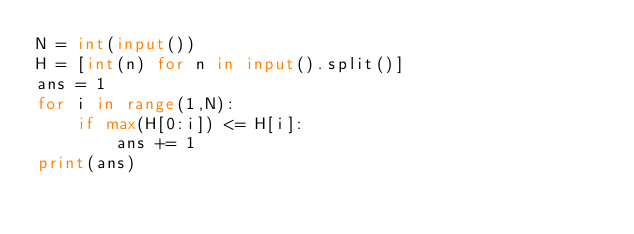Convert code to text. <code><loc_0><loc_0><loc_500><loc_500><_Python_>N = int(input())
H = [int(n) for n in input().split()]
ans = 1
for i in range(1,N):
    if max(H[0:i]) <= H[i]:
        ans += 1
print(ans)</code> 